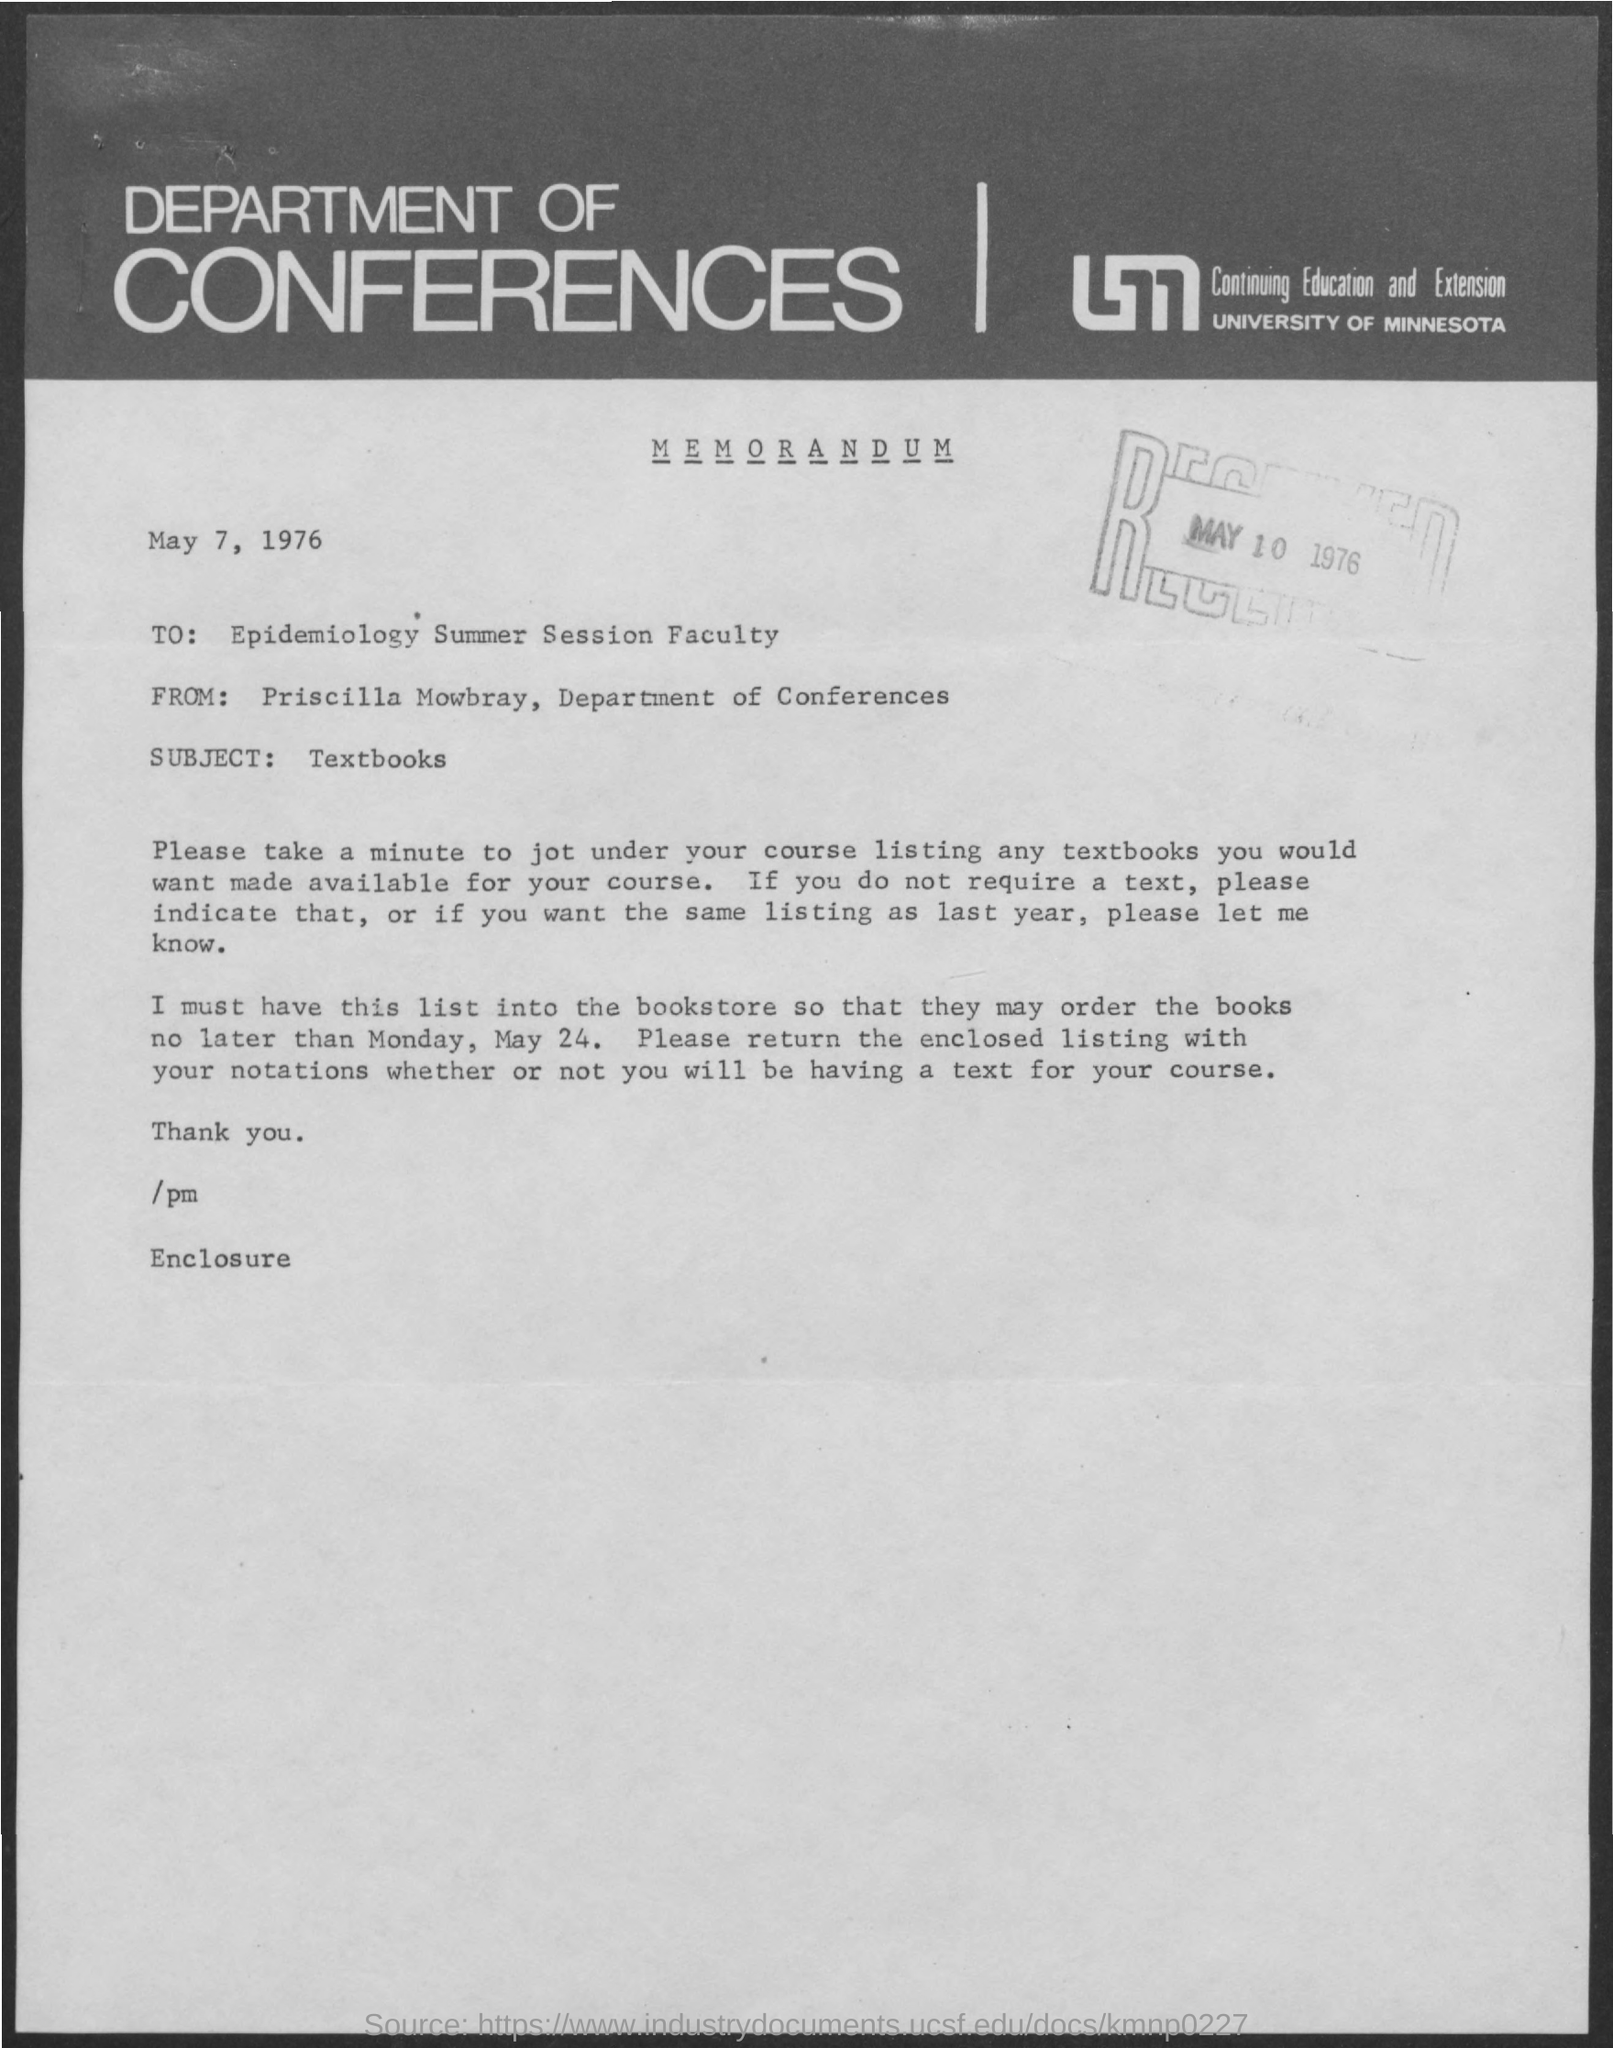Draw attention to some important aspects in this diagram. This memorandum is addressed to the faculty of the Epidemiology Summer Session. The document indicates that the date is May 7, 1976. The subject of the sentence is "textbooks. 